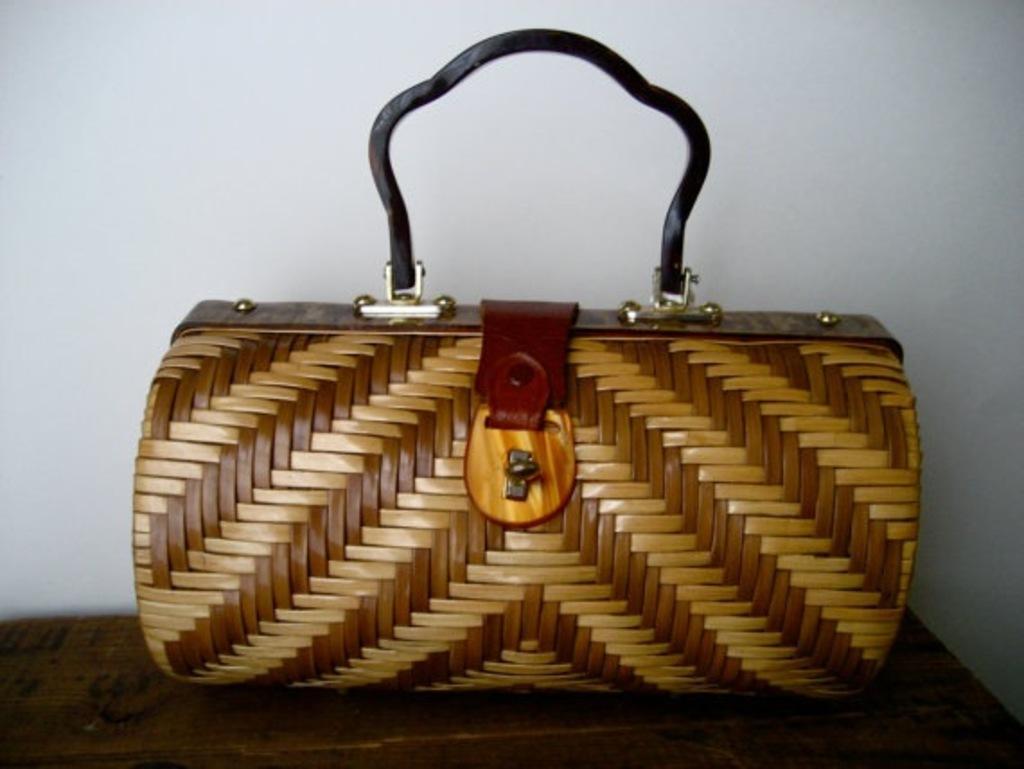In one or two sentences, can you explain what this image depicts? I can see a brown color handbag in this image. 